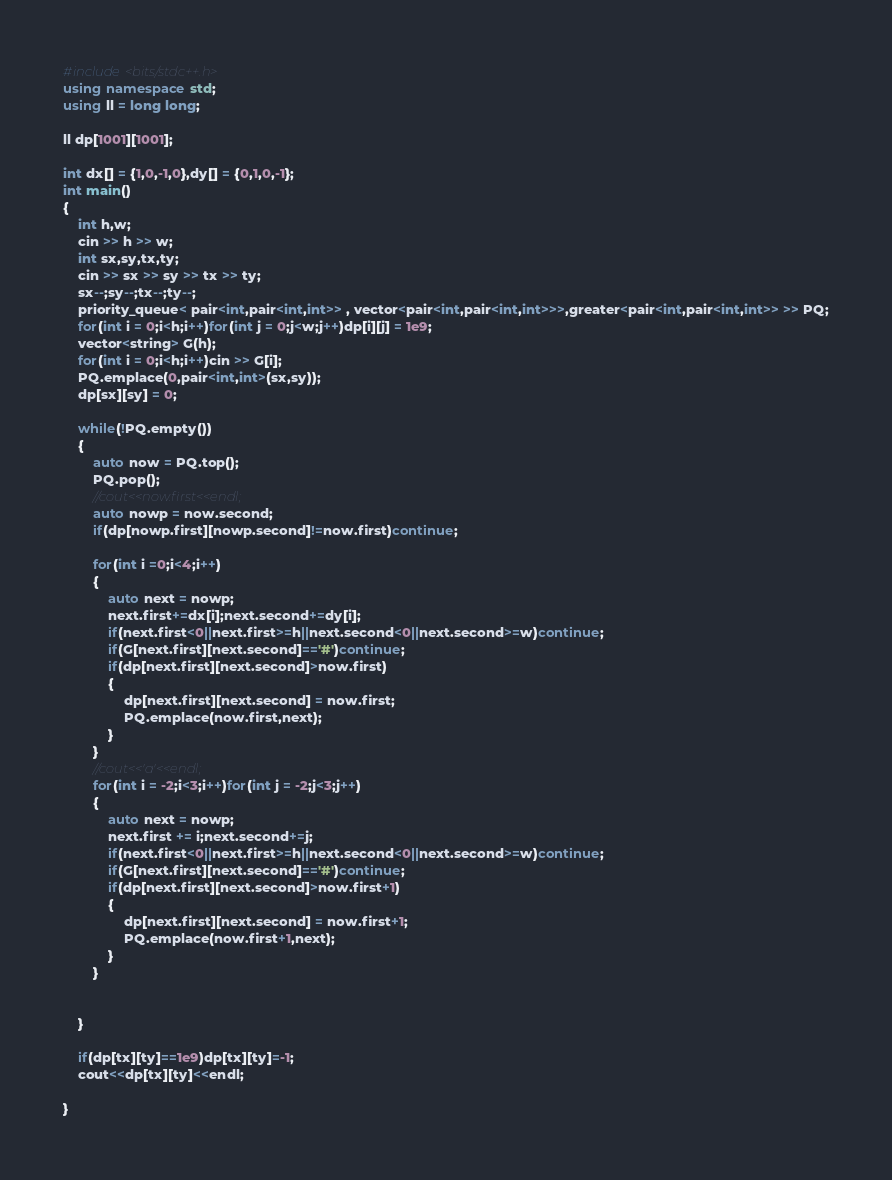<code> <loc_0><loc_0><loc_500><loc_500><_C++_>#include<bits/stdc++.h>
using namespace std;
using ll = long long;

ll dp[1001][1001];

int dx[] = {1,0,-1,0},dy[] = {0,1,0,-1};
int main()
{
	int h,w;
	cin >> h >> w;
	int sx,sy,tx,ty;
	cin >> sx >> sy >> tx >> ty;
	sx--;sy--;tx--;ty--;
	priority_queue< pair<int,pair<int,int>> , vector<pair<int,pair<int,int>>>,greater<pair<int,pair<int,int>> >> PQ;
	for(int i = 0;i<h;i++)for(int j = 0;j<w;j++)dp[i][j] = 1e9;
	vector<string> G(h);
	for(int i = 0;i<h;i++)cin >> G[i];
	PQ.emplace(0,pair<int,int>(sx,sy));
	dp[sx][sy] = 0;

	while(!PQ.empty())
	{
		auto now = PQ.top();
		PQ.pop();
		//cout<<now.first<<endl;
		auto nowp = now.second;
		if(dp[nowp.first][nowp.second]!=now.first)continue;

		for(int i =0;i<4;i++)
		{
			auto next = nowp;
			next.first+=dx[i];next.second+=dy[i];
			if(next.first<0||next.first>=h||next.second<0||next.second>=w)continue;
			if(G[next.first][next.second]=='#')continue;
			if(dp[next.first][next.second]>now.first)
			{
				dp[next.first][next.second] = now.first;
				PQ.emplace(now.first,next);
			}
		}
		//cout<<'a'<<endl;
		for(int i = -2;i<3;i++)for(int j = -2;j<3;j++)
		{
			auto next = nowp;
			next.first += i;next.second+=j;
			if(next.first<0||next.first>=h||next.second<0||next.second>=w)continue;
			if(G[next.first][next.second]=='#')continue;
			if(dp[next.first][next.second]>now.first+1)
			{
				dp[next.first][next.second] = now.first+1;
				PQ.emplace(now.first+1,next);
			}
		}

		
	}

	if(dp[tx][ty]==1e9)dp[tx][ty]=-1;
	cout<<dp[tx][ty]<<endl;

}
</code> 